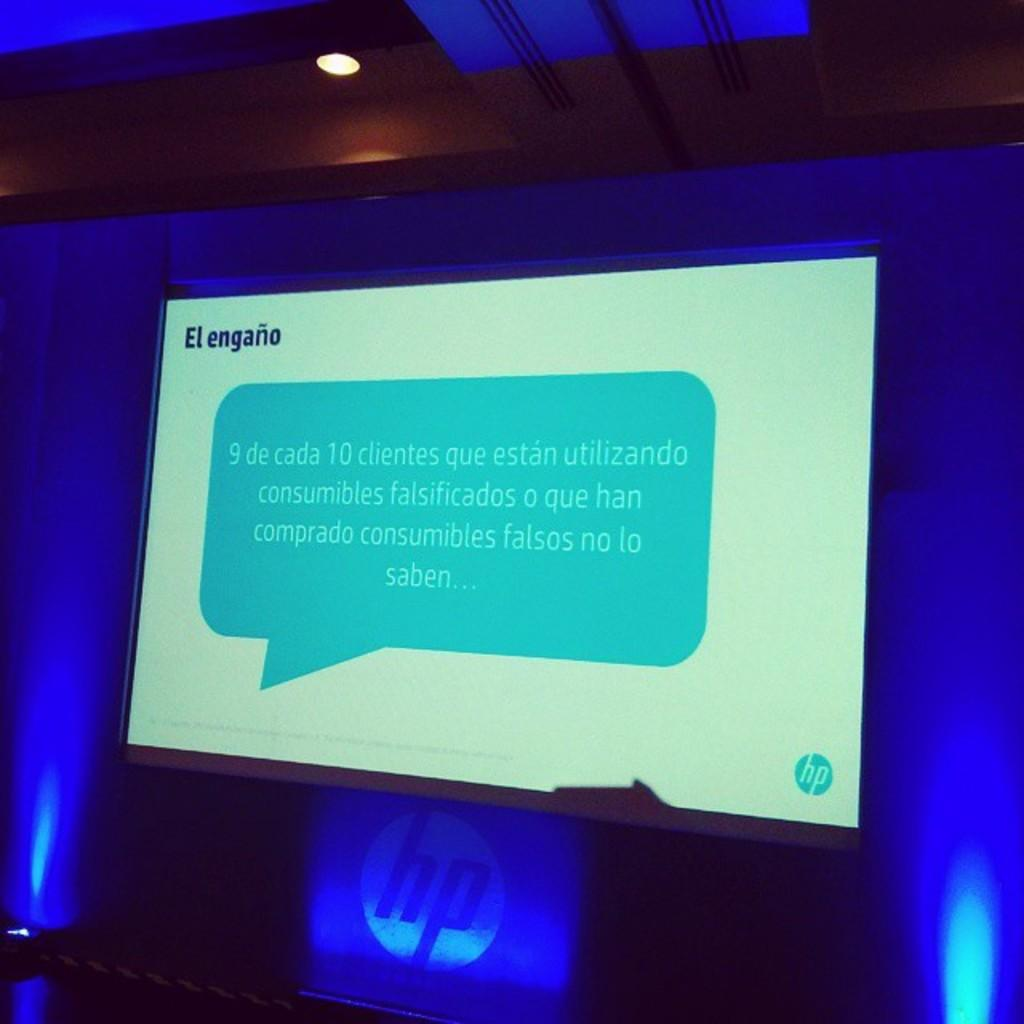<image>
Share a concise interpretation of the image provided. a presentation that has an hp logo on it 